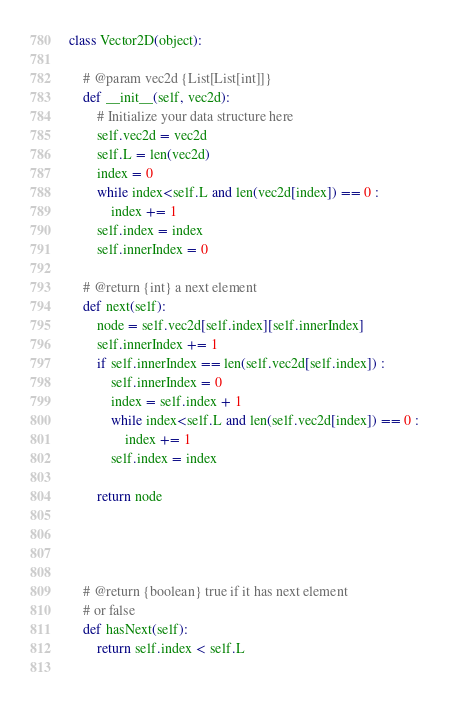Convert code to text. <code><loc_0><loc_0><loc_500><loc_500><_Python_>class Vector2D(object):

    # @param vec2d {List[List[int]]}
    def __init__(self, vec2d):
        # Initialize your data structure here
        self.vec2d = vec2d
        self.L = len(vec2d)
        index = 0
        while index<self.L and len(vec2d[index]) == 0 :
            index += 1
        self.index = index
        self.innerIndex = 0

    # @return {int} a next element
    def next(self):
        node = self.vec2d[self.index][self.innerIndex]
        self.innerIndex += 1
        if self.innerIndex == len(self.vec2d[self.index]) :
            self.innerIndex = 0
            index = self.index + 1
            while index<self.L and len(self.vec2d[index]) == 0 :
                index += 1
            self.index = index
        
        return node


        

    # @return {boolean} true if it has next element
    # or false
    def hasNext(self):
        return self.index < self.L
        

</code> 